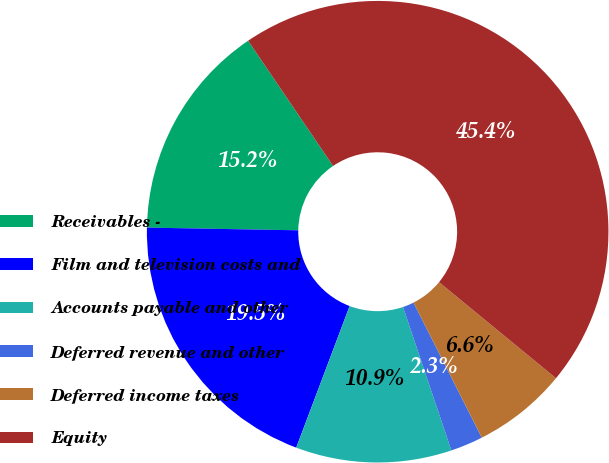Convert chart to OTSL. <chart><loc_0><loc_0><loc_500><loc_500><pie_chart><fcel>Receivables -<fcel>Film and television costs and<fcel>Accounts payable and other<fcel>Deferred revenue and other<fcel>Deferred income taxes<fcel>Equity<nl><fcel>15.23%<fcel>19.54%<fcel>10.91%<fcel>2.28%<fcel>6.6%<fcel>45.43%<nl></chart> 